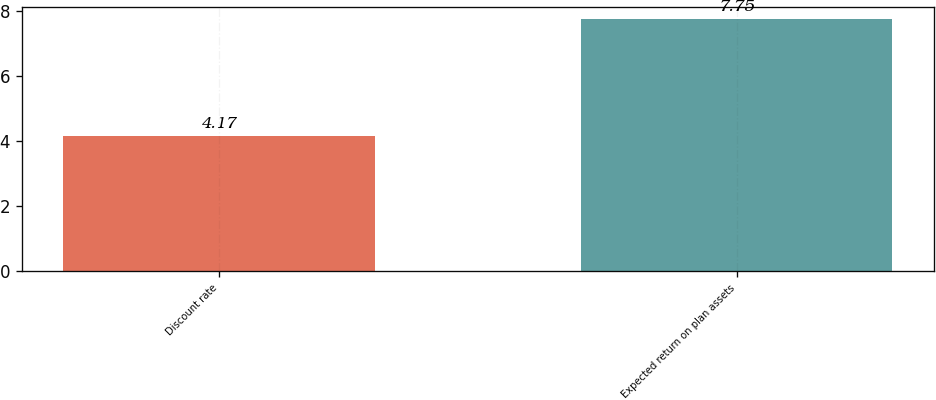Convert chart. <chart><loc_0><loc_0><loc_500><loc_500><bar_chart><fcel>Discount rate<fcel>Expected return on plan assets<nl><fcel>4.17<fcel>7.75<nl></chart> 